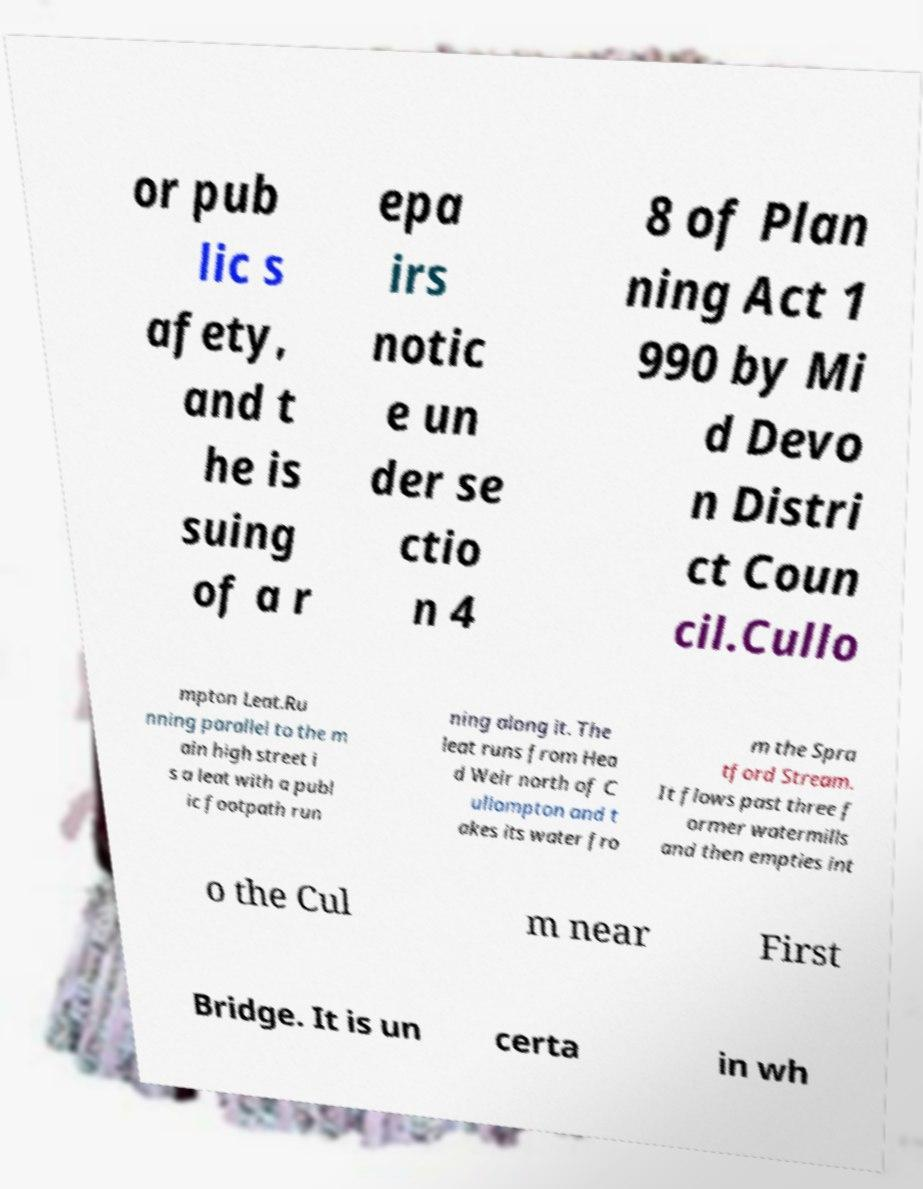What messages or text are displayed in this image? I need them in a readable, typed format. or pub lic s afety, and t he is suing of a r epa irs notic e un der se ctio n 4 8 of Plan ning Act 1 990 by Mi d Devo n Distri ct Coun cil.Cullo mpton Leat.Ru nning parallel to the m ain high street i s a leat with a publ ic footpath run ning along it. The leat runs from Hea d Weir north of C ullompton and t akes its water fro m the Spra tford Stream. It flows past three f ormer watermills and then empties int o the Cul m near First Bridge. It is un certa in wh 